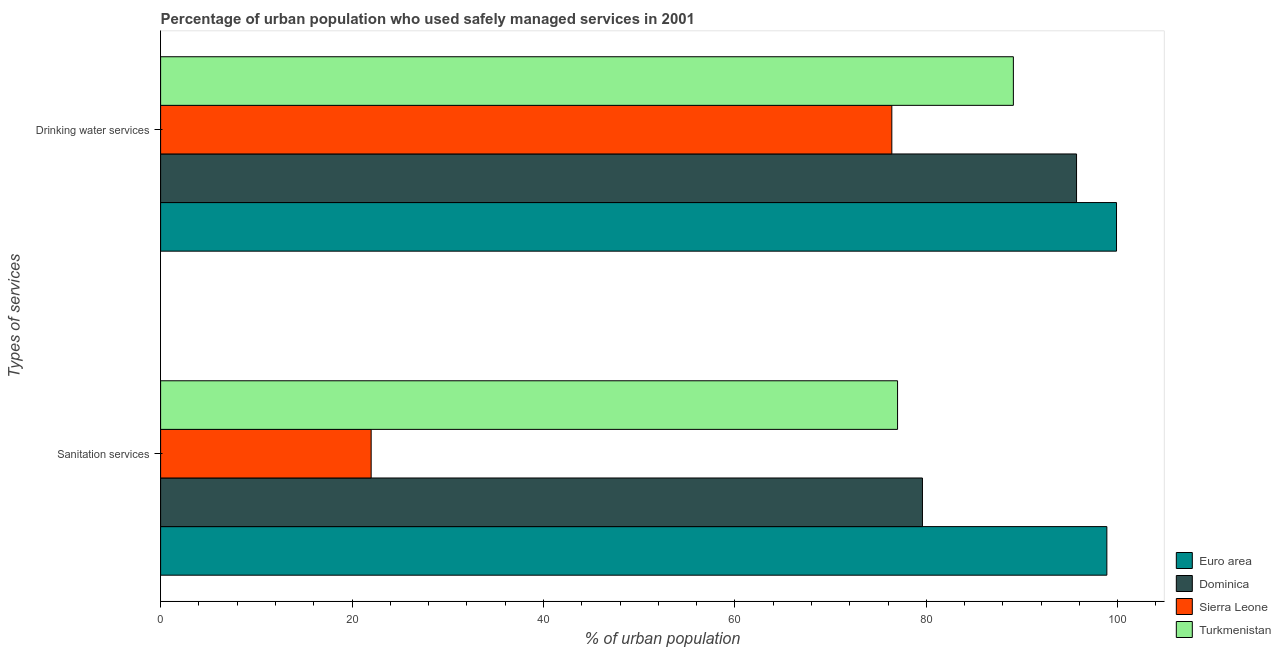How many groups of bars are there?
Provide a short and direct response. 2. Are the number of bars per tick equal to the number of legend labels?
Give a very brief answer. Yes. How many bars are there on the 1st tick from the top?
Make the answer very short. 4. What is the label of the 1st group of bars from the top?
Ensure brevity in your answer.  Drinking water services. What is the percentage of urban population who used drinking water services in Sierra Leone?
Provide a short and direct response. 76.4. Across all countries, what is the maximum percentage of urban population who used drinking water services?
Keep it short and to the point. 99.88. In which country was the percentage of urban population who used drinking water services maximum?
Your response must be concise. Euro area. In which country was the percentage of urban population who used sanitation services minimum?
Make the answer very short. Sierra Leone. What is the total percentage of urban population who used drinking water services in the graph?
Provide a succinct answer. 361.08. What is the difference between the percentage of urban population who used sanitation services in Turkmenistan and that in Euro area?
Ensure brevity in your answer.  -21.87. What is the difference between the percentage of urban population who used drinking water services in Turkmenistan and the percentage of urban population who used sanitation services in Euro area?
Keep it short and to the point. -9.77. What is the average percentage of urban population who used drinking water services per country?
Keep it short and to the point. 90.27. What is the difference between the percentage of urban population who used sanitation services and percentage of urban population who used drinking water services in Dominica?
Provide a succinct answer. -16.1. What is the ratio of the percentage of urban population who used sanitation services in Sierra Leone to that in Dominica?
Your response must be concise. 0.28. What does the 2nd bar from the top in Sanitation services represents?
Offer a terse response. Sierra Leone. What does the 4th bar from the bottom in Drinking water services represents?
Your answer should be very brief. Turkmenistan. How many bars are there?
Your answer should be very brief. 8. Are all the bars in the graph horizontal?
Make the answer very short. Yes. Are the values on the major ticks of X-axis written in scientific E-notation?
Keep it short and to the point. No. How many legend labels are there?
Your answer should be very brief. 4. What is the title of the graph?
Offer a terse response. Percentage of urban population who used safely managed services in 2001. Does "Channel Islands" appear as one of the legend labels in the graph?
Offer a terse response. No. What is the label or title of the X-axis?
Offer a terse response. % of urban population. What is the label or title of the Y-axis?
Your answer should be very brief. Types of services. What is the % of urban population in Euro area in Sanitation services?
Provide a short and direct response. 98.87. What is the % of urban population in Dominica in Sanitation services?
Keep it short and to the point. 79.6. What is the % of urban population in Turkmenistan in Sanitation services?
Your answer should be very brief. 77. What is the % of urban population of Euro area in Drinking water services?
Offer a terse response. 99.88. What is the % of urban population of Dominica in Drinking water services?
Provide a succinct answer. 95.7. What is the % of urban population of Sierra Leone in Drinking water services?
Give a very brief answer. 76.4. What is the % of urban population in Turkmenistan in Drinking water services?
Offer a terse response. 89.1. Across all Types of services, what is the maximum % of urban population of Euro area?
Your answer should be compact. 99.88. Across all Types of services, what is the maximum % of urban population in Dominica?
Your answer should be very brief. 95.7. Across all Types of services, what is the maximum % of urban population in Sierra Leone?
Offer a very short reply. 76.4. Across all Types of services, what is the maximum % of urban population of Turkmenistan?
Keep it short and to the point. 89.1. Across all Types of services, what is the minimum % of urban population in Euro area?
Provide a succinct answer. 98.87. Across all Types of services, what is the minimum % of urban population of Dominica?
Your answer should be compact. 79.6. Across all Types of services, what is the minimum % of urban population of Turkmenistan?
Your answer should be compact. 77. What is the total % of urban population of Euro area in the graph?
Ensure brevity in your answer.  198.74. What is the total % of urban population of Dominica in the graph?
Provide a succinct answer. 175.3. What is the total % of urban population of Sierra Leone in the graph?
Provide a short and direct response. 98.4. What is the total % of urban population in Turkmenistan in the graph?
Keep it short and to the point. 166.1. What is the difference between the % of urban population of Euro area in Sanitation services and that in Drinking water services?
Provide a succinct answer. -1.01. What is the difference between the % of urban population of Dominica in Sanitation services and that in Drinking water services?
Provide a succinct answer. -16.1. What is the difference between the % of urban population of Sierra Leone in Sanitation services and that in Drinking water services?
Provide a short and direct response. -54.4. What is the difference between the % of urban population in Euro area in Sanitation services and the % of urban population in Dominica in Drinking water services?
Your answer should be very brief. 3.17. What is the difference between the % of urban population of Euro area in Sanitation services and the % of urban population of Sierra Leone in Drinking water services?
Ensure brevity in your answer.  22.47. What is the difference between the % of urban population of Euro area in Sanitation services and the % of urban population of Turkmenistan in Drinking water services?
Keep it short and to the point. 9.77. What is the difference between the % of urban population of Dominica in Sanitation services and the % of urban population of Sierra Leone in Drinking water services?
Make the answer very short. 3.2. What is the difference between the % of urban population in Sierra Leone in Sanitation services and the % of urban population in Turkmenistan in Drinking water services?
Your answer should be very brief. -67.1. What is the average % of urban population of Euro area per Types of services?
Give a very brief answer. 99.37. What is the average % of urban population in Dominica per Types of services?
Offer a very short reply. 87.65. What is the average % of urban population in Sierra Leone per Types of services?
Ensure brevity in your answer.  49.2. What is the average % of urban population in Turkmenistan per Types of services?
Keep it short and to the point. 83.05. What is the difference between the % of urban population of Euro area and % of urban population of Dominica in Sanitation services?
Your answer should be very brief. 19.27. What is the difference between the % of urban population of Euro area and % of urban population of Sierra Leone in Sanitation services?
Give a very brief answer. 76.87. What is the difference between the % of urban population of Euro area and % of urban population of Turkmenistan in Sanitation services?
Offer a very short reply. 21.87. What is the difference between the % of urban population of Dominica and % of urban population of Sierra Leone in Sanitation services?
Offer a terse response. 57.6. What is the difference between the % of urban population in Sierra Leone and % of urban population in Turkmenistan in Sanitation services?
Your answer should be compact. -55. What is the difference between the % of urban population in Euro area and % of urban population in Dominica in Drinking water services?
Keep it short and to the point. 4.18. What is the difference between the % of urban population of Euro area and % of urban population of Sierra Leone in Drinking water services?
Make the answer very short. 23.48. What is the difference between the % of urban population of Euro area and % of urban population of Turkmenistan in Drinking water services?
Provide a short and direct response. 10.78. What is the difference between the % of urban population in Dominica and % of urban population in Sierra Leone in Drinking water services?
Your response must be concise. 19.3. What is the ratio of the % of urban population of Euro area in Sanitation services to that in Drinking water services?
Provide a succinct answer. 0.99. What is the ratio of the % of urban population of Dominica in Sanitation services to that in Drinking water services?
Give a very brief answer. 0.83. What is the ratio of the % of urban population in Sierra Leone in Sanitation services to that in Drinking water services?
Make the answer very short. 0.29. What is the ratio of the % of urban population in Turkmenistan in Sanitation services to that in Drinking water services?
Provide a succinct answer. 0.86. What is the difference between the highest and the second highest % of urban population of Euro area?
Offer a very short reply. 1.01. What is the difference between the highest and the second highest % of urban population of Sierra Leone?
Make the answer very short. 54.4. What is the difference between the highest and the second highest % of urban population in Turkmenistan?
Your answer should be very brief. 12.1. What is the difference between the highest and the lowest % of urban population of Euro area?
Your answer should be very brief. 1.01. What is the difference between the highest and the lowest % of urban population in Sierra Leone?
Offer a terse response. 54.4. What is the difference between the highest and the lowest % of urban population of Turkmenistan?
Offer a very short reply. 12.1. 